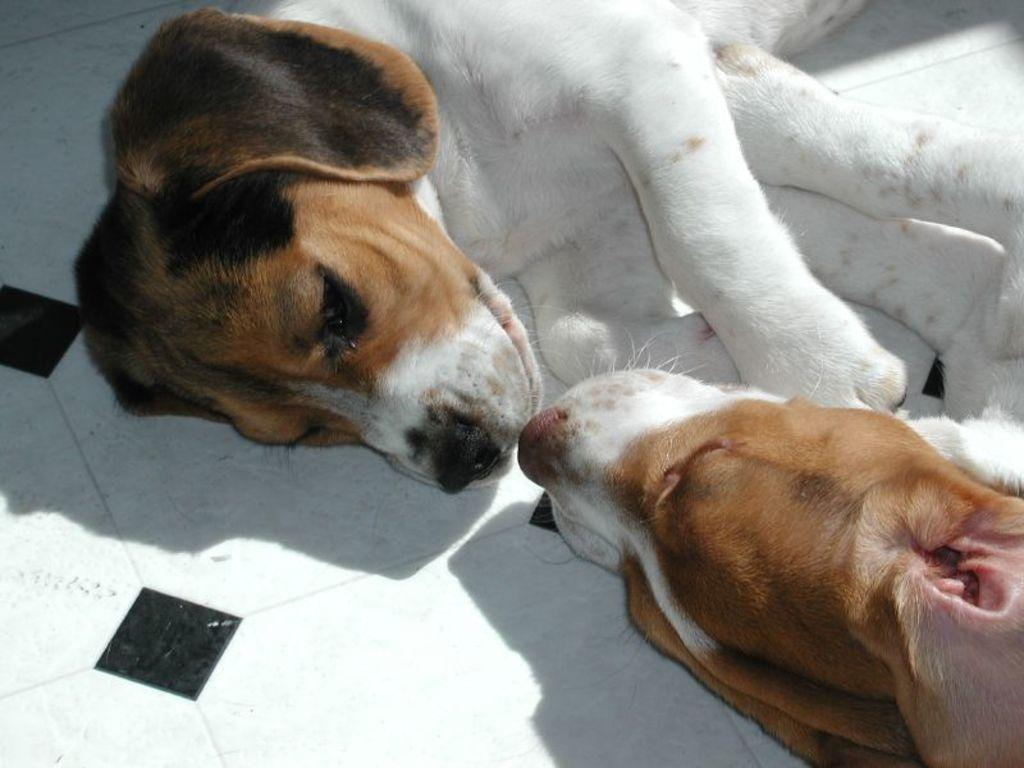How many dogs are present in the image? There are two dogs in the image. What are the dogs doing in the image? The dogs are lying on the floor. How many spiders are crawling on the wall in the image? There are no spiders or walls present in the image; it features two dogs lying on the floor. 